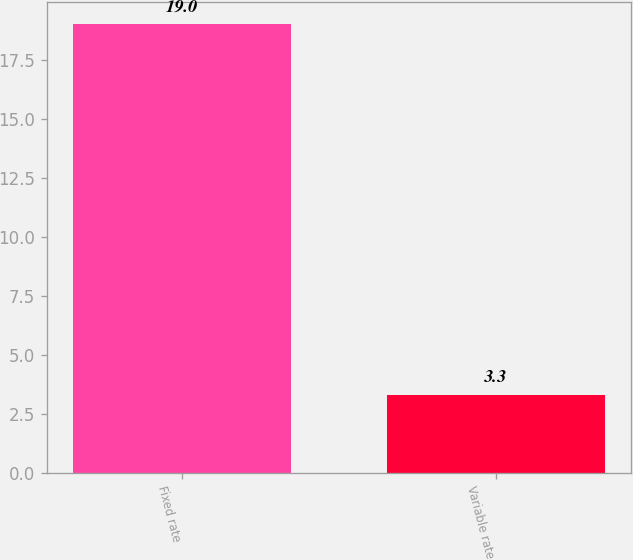<chart> <loc_0><loc_0><loc_500><loc_500><bar_chart><fcel>Fixed rate<fcel>Variable rate<nl><fcel>19<fcel>3.3<nl></chart> 